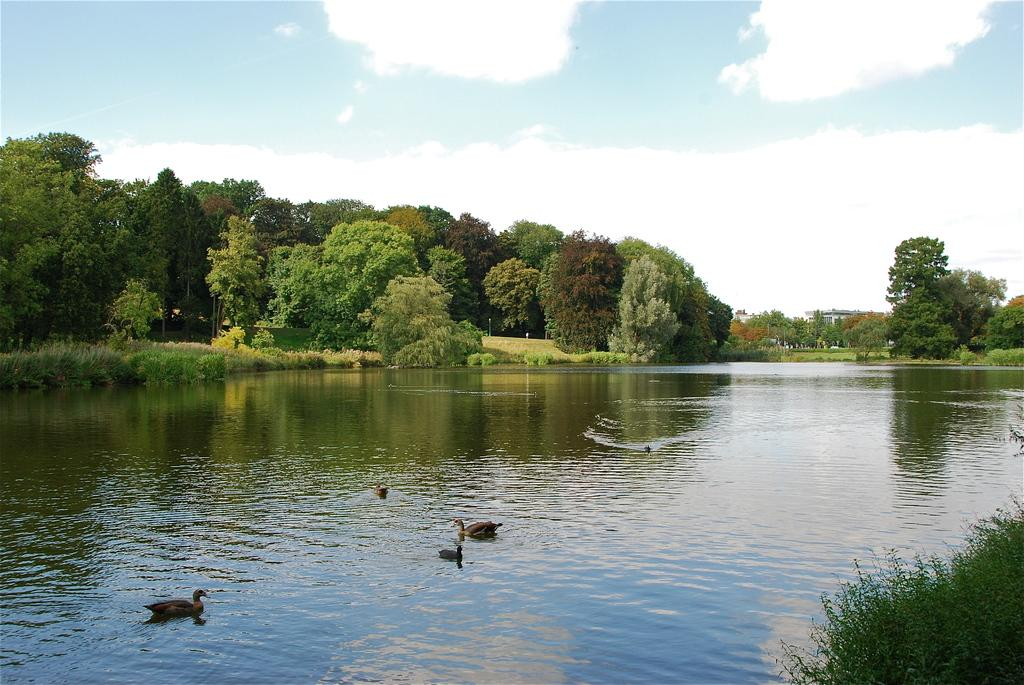Where was the image taken? The image was clicked outside. What is the main subject in the middle of the image? There is water and trees in the middle of the image. What is visible at the top of the image? The sky is visible at the top of the image. What animals can be seen in the water? There are ducks in the water. What type of attraction is present in the image? There is no attraction present in the image; it features water, trees, ducks, and the sky. Can you tell me how many aunts are visible in the image? There are no aunts present in the image. 